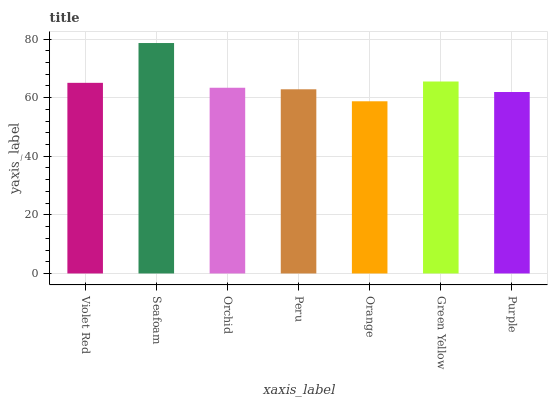Is Orchid the minimum?
Answer yes or no. No. Is Orchid the maximum?
Answer yes or no. No. Is Seafoam greater than Orchid?
Answer yes or no. Yes. Is Orchid less than Seafoam?
Answer yes or no. Yes. Is Orchid greater than Seafoam?
Answer yes or no. No. Is Seafoam less than Orchid?
Answer yes or no. No. Is Orchid the high median?
Answer yes or no. Yes. Is Orchid the low median?
Answer yes or no. Yes. Is Seafoam the high median?
Answer yes or no. No. Is Seafoam the low median?
Answer yes or no. No. 